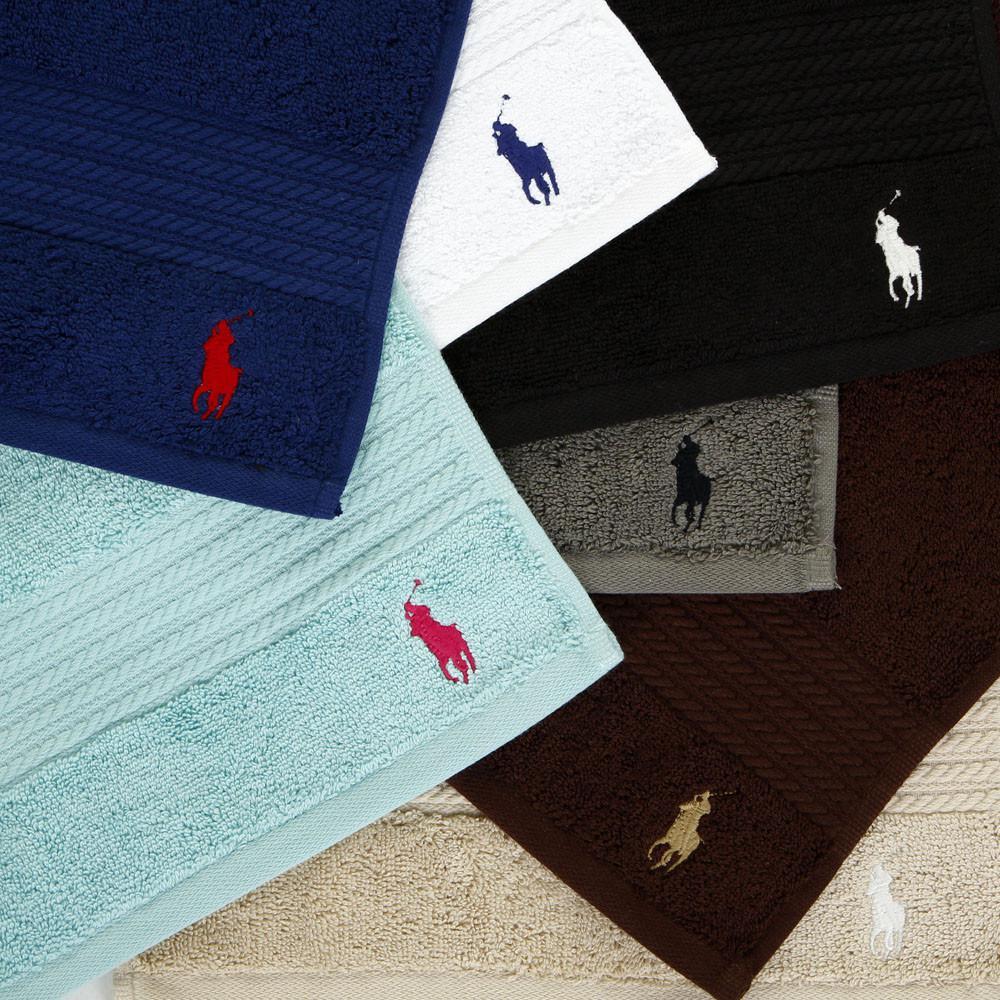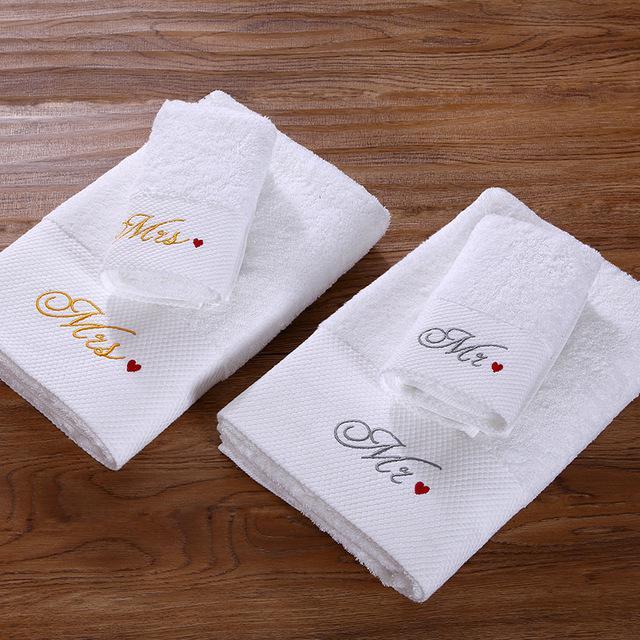The first image is the image on the left, the second image is the image on the right. For the images shown, is this caption "The right image contains only white towels, while the left image has at least one blue towel." true? Answer yes or no. Yes. 